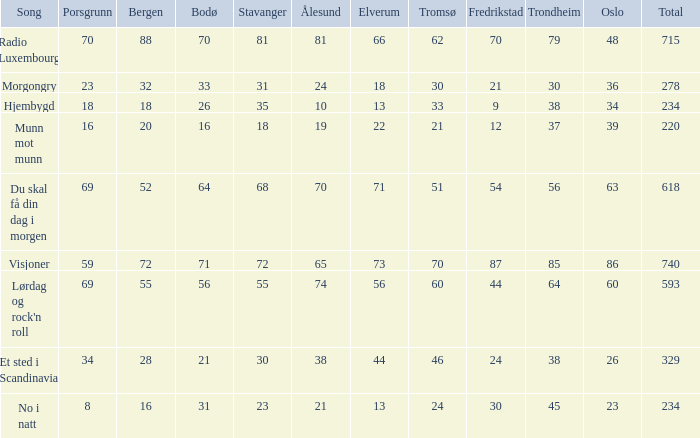What is the lowest total? 220.0. 